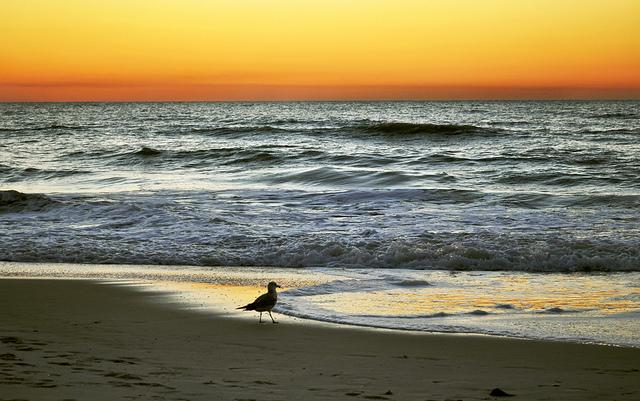Is the bird in the photo a seagull?
Write a very short answer. Yes. Is the water wavy?
Keep it brief. Yes. Why is the horizon curved?
Be succinct. Light refraction. 